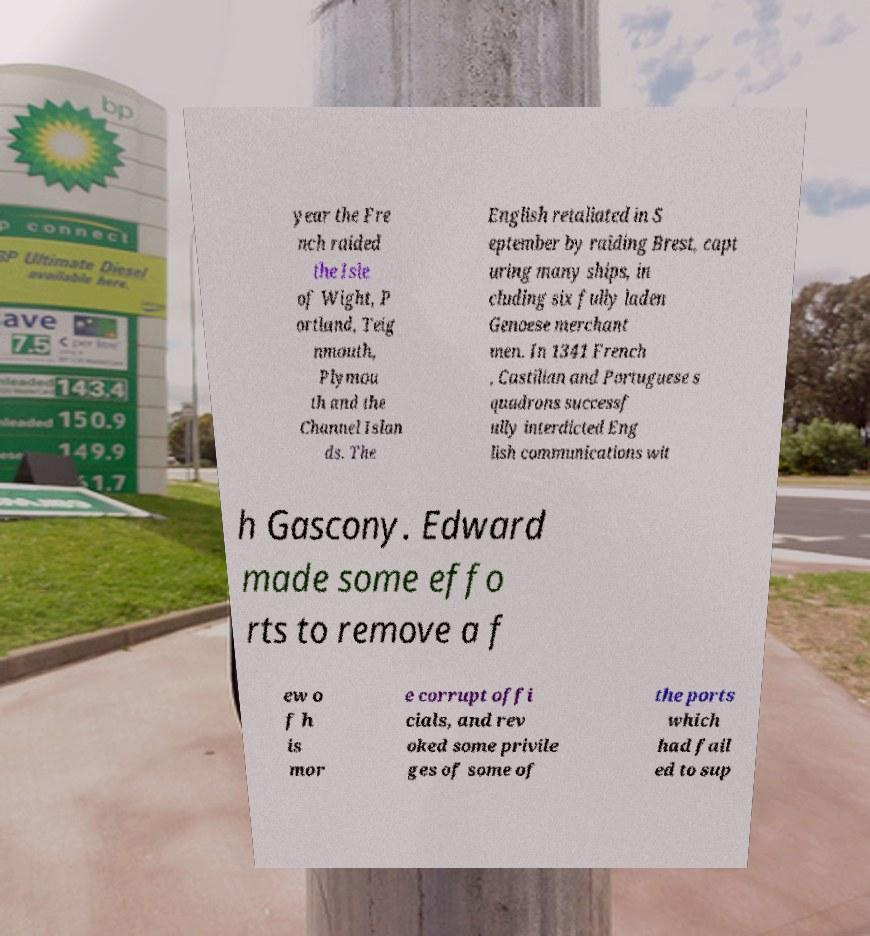Can you accurately transcribe the text from the provided image for me? year the Fre nch raided the Isle of Wight, P ortland, Teig nmouth, Plymou th and the Channel Islan ds. The English retaliated in S eptember by raiding Brest, capt uring many ships, in cluding six fully laden Genoese merchant men. In 1341 French , Castilian and Portuguese s quadrons successf ully interdicted Eng lish communications wit h Gascony. Edward made some effo rts to remove a f ew o f h is mor e corrupt offi cials, and rev oked some privile ges of some of the ports which had fail ed to sup 